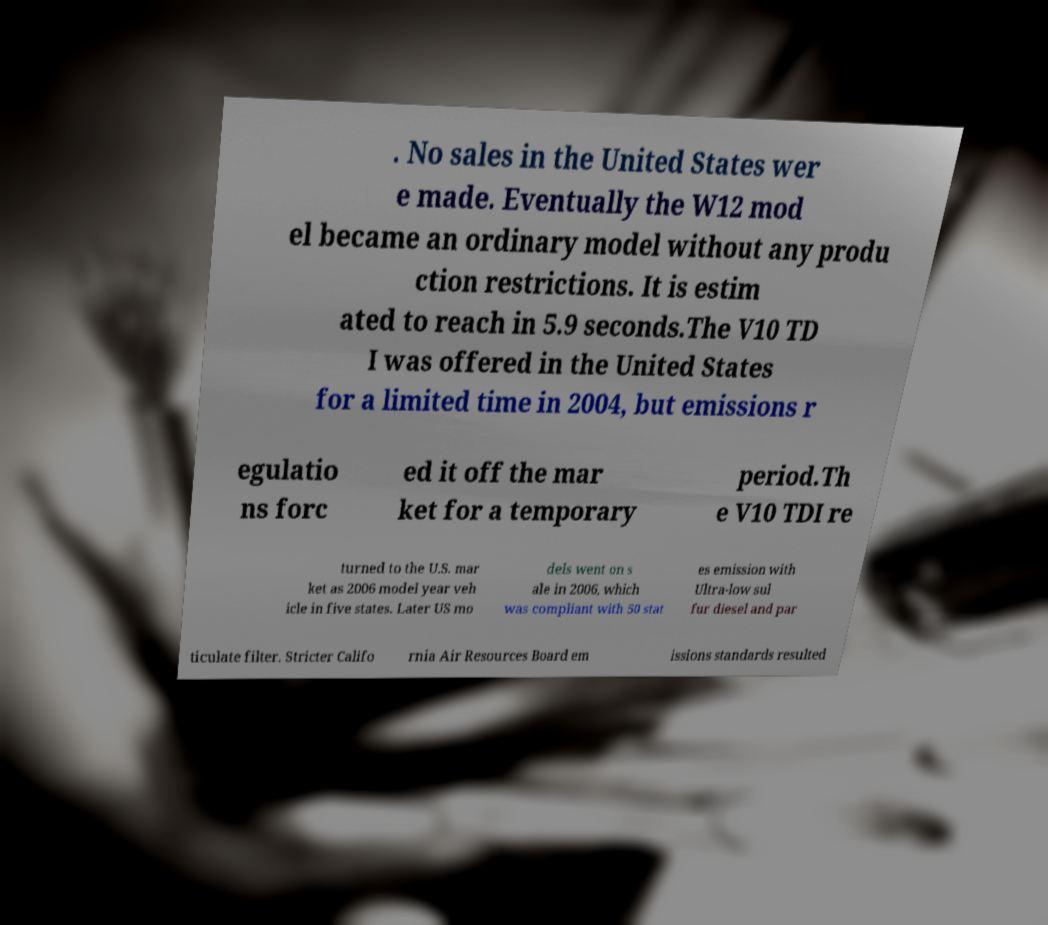Could you assist in decoding the text presented in this image and type it out clearly? . No sales in the United States wer e made. Eventually the W12 mod el became an ordinary model without any produ ction restrictions. It is estim ated to reach in 5.9 seconds.The V10 TD I was offered in the United States for a limited time in 2004, but emissions r egulatio ns forc ed it off the mar ket for a temporary period.Th e V10 TDI re turned to the U.S. mar ket as 2006 model year veh icle in five states. Later US mo dels went on s ale in 2006, which was compliant with 50 stat es emission with Ultra-low sul fur diesel and par ticulate filter. Stricter Califo rnia Air Resources Board em issions standards resulted 